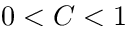<formula> <loc_0><loc_0><loc_500><loc_500>0 < C < 1</formula> 